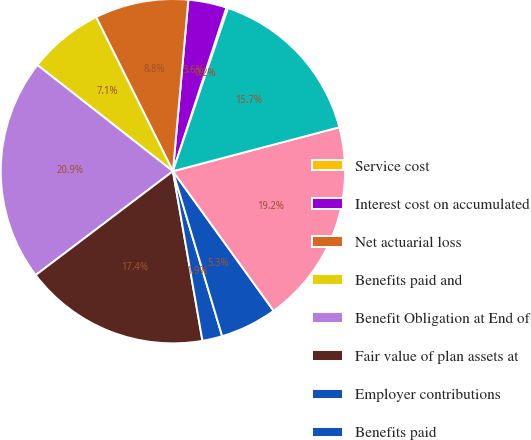<chart> <loc_0><loc_0><loc_500><loc_500><pie_chart><fcel>Service cost<fcel>Interest cost on accumulated<fcel>Net actuarial loss<fcel>Benefits paid and<fcel>Benefit Obligation at End of<fcel>Fair value of plan assets at<fcel>Employer contributions<fcel>Benefits paid<fcel>Fair Value of Plan Assets at<fcel>Funded status<nl><fcel>0.15%<fcel>3.6%<fcel>8.79%<fcel>7.06%<fcel>20.89%<fcel>17.43%<fcel>1.87%<fcel>5.33%<fcel>19.16%<fcel>15.71%<nl></chart> 